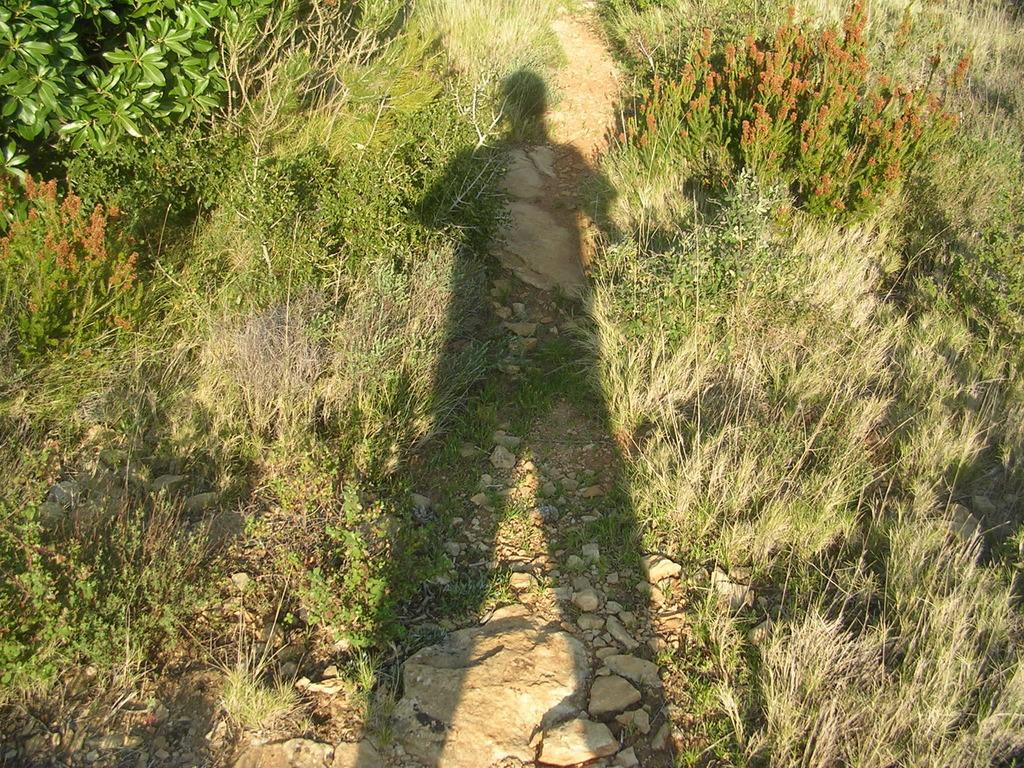What type of vegetation can be seen in the image? There are plants in the image. What type of ground cover is present in the image? There is grass in the image. What can be observed on the grass in the image? There is a shadow on the grass. What is located at the bottom of the image? There are stones at the bottom of the image. What is the purpose of the destruction in the image? There is no destruction present in the image, so it is not possible to determine its purpose. 